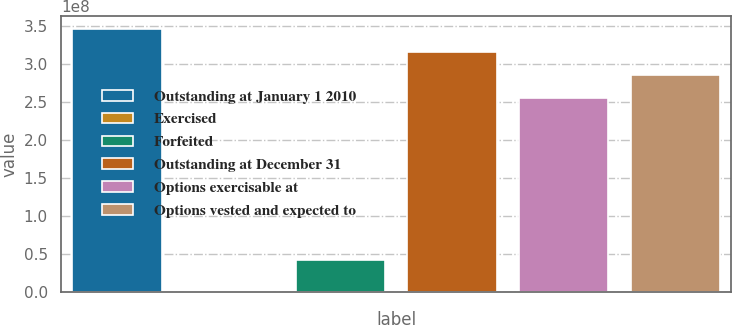<chart> <loc_0><loc_0><loc_500><loc_500><bar_chart><fcel>Outstanding at January 1 2010<fcel>Exercised<fcel>Forfeited<fcel>Outstanding at December 31<fcel>Options exercisable at<fcel>Options vested and expected to<nl><fcel>3.46731e+08<fcel>4959<fcel>4.2595e+07<fcel>3.16359e+08<fcel>2.55616e+08<fcel>2.85988e+08<nl></chart> 